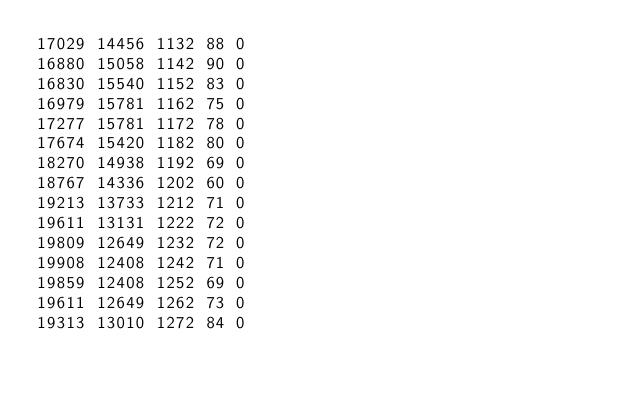Convert code to text. <code><loc_0><loc_0><loc_500><loc_500><_SML_>17029 14456 1132 88 0
16880 15058 1142 90 0
16830 15540 1152 83 0
16979 15781 1162 75 0
17277 15781 1172 78 0
17674 15420 1182 80 0
18270 14938 1192 69 0
18767 14336 1202 60 0
19213 13733 1212 71 0
19611 13131 1222 72 0
19809 12649 1232 72 0
19908 12408 1242 71 0
19859 12408 1252 69 0
19611 12649 1262 73 0
19313 13010 1272 84 0</code> 